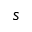Convert formula to latex. <formula><loc_0><loc_0><loc_500><loc_500>s</formula> 